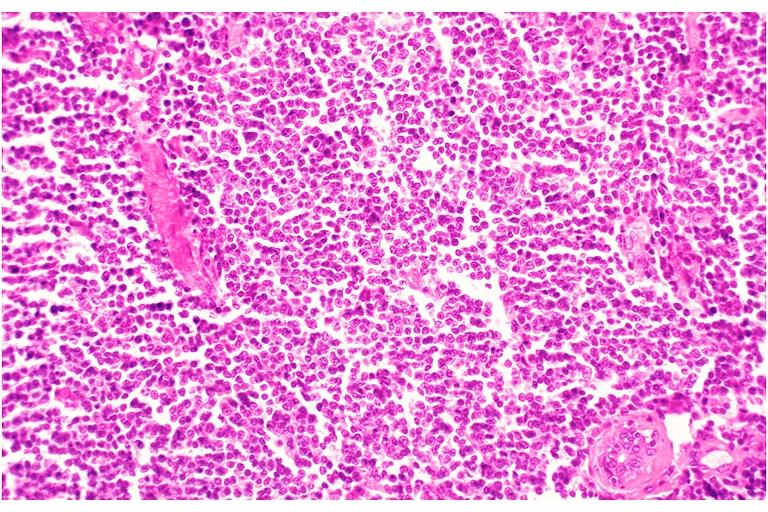does this image show leukemic infiltrate?
Answer the question using a single word or phrase. Yes 